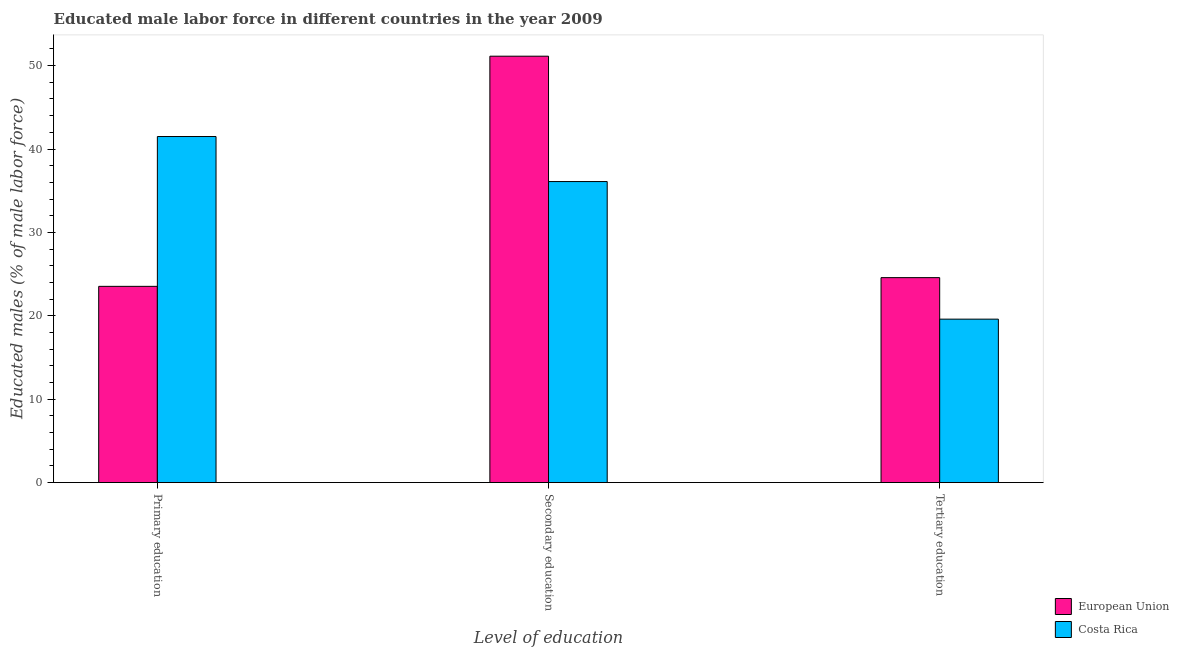How many different coloured bars are there?
Your answer should be compact. 2. How many groups of bars are there?
Give a very brief answer. 3. Are the number of bars per tick equal to the number of legend labels?
Your response must be concise. Yes. How many bars are there on the 1st tick from the left?
Provide a succinct answer. 2. What is the label of the 2nd group of bars from the left?
Your answer should be compact. Secondary education. What is the percentage of male labor force who received primary education in European Union?
Keep it short and to the point. 23.53. Across all countries, what is the maximum percentage of male labor force who received primary education?
Give a very brief answer. 41.5. Across all countries, what is the minimum percentage of male labor force who received secondary education?
Make the answer very short. 36.1. In which country was the percentage of male labor force who received tertiary education minimum?
Give a very brief answer. Costa Rica. What is the total percentage of male labor force who received primary education in the graph?
Provide a succinct answer. 65.03. What is the difference between the percentage of male labor force who received secondary education in Costa Rica and that in European Union?
Make the answer very short. -15.03. What is the difference between the percentage of male labor force who received primary education in European Union and the percentage of male labor force who received tertiary education in Costa Rica?
Offer a terse response. 3.93. What is the average percentage of male labor force who received tertiary education per country?
Provide a succinct answer. 22.09. What is the difference between the percentage of male labor force who received secondary education and percentage of male labor force who received tertiary education in European Union?
Keep it short and to the point. 26.55. What is the ratio of the percentage of male labor force who received primary education in European Union to that in Costa Rica?
Provide a succinct answer. 0.57. Is the percentage of male labor force who received primary education in Costa Rica less than that in European Union?
Make the answer very short. No. What is the difference between the highest and the second highest percentage of male labor force who received secondary education?
Offer a terse response. 15.03. What is the difference between the highest and the lowest percentage of male labor force who received tertiary education?
Provide a short and direct response. 4.98. Is the sum of the percentage of male labor force who received tertiary education in Costa Rica and European Union greater than the maximum percentage of male labor force who received primary education across all countries?
Make the answer very short. Yes. What does the 2nd bar from the right in Primary education represents?
Your response must be concise. European Union. How many bars are there?
Ensure brevity in your answer.  6. How many countries are there in the graph?
Ensure brevity in your answer.  2. What is the difference between two consecutive major ticks on the Y-axis?
Provide a short and direct response. 10. Are the values on the major ticks of Y-axis written in scientific E-notation?
Your answer should be compact. No. Where does the legend appear in the graph?
Offer a terse response. Bottom right. How many legend labels are there?
Your answer should be very brief. 2. What is the title of the graph?
Ensure brevity in your answer.  Educated male labor force in different countries in the year 2009. What is the label or title of the X-axis?
Make the answer very short. Level of education. What is the label or title of the Y-axis?
Provide a succinct answer. Educated males (% of male labor force). What is the Educated males (% of male labor force) in European Union in Primary education?
Ensure brevity in your answer.  23.53. What is the Educated males (% of male labor force) in Costa Rica in Primary education?
Keep it short and to the point. 41.5. What is the Educated males (% of male labor force) of European Union in Secondary education?
Make the answer very short. 51.13. What is the Educated males (% of male labor force) in Costa Rica in Secondary education?
Make the answer very short. 36.1. What is the Educated males (% of male labor force) in European Union in Tertiary education?
Offer a terse response. 24.58. What is the Educated males (% of male labor force) in Costa Rica in Tertiary education?
Provide a short and direct response. 19.6. Across all Level of education, what is the maximum Educated males (% of male labor force) in European Union?
Your response must be concise. 51.13. Across all Level of education, what is the maximum Educated males (% of male labor force) of Costa Rica?
Your response must be concise. 41.5. Across all Level of education, what is the minimum Educated males (% of male labor force) in European Union?
Make the answer very short. 23.53. Across all Level of education, what is the minimum Educated males (% of male labor force) in Costa Rica?
Make the answer very short. 19.6. What is the total Educated males (% of male labor force) in European Union in the graph?
Your answer should be very brief. 99.24. What is the total Educated males (% of male labor force) in Costa Rica in the graph?
Keep it short and to the point. 97.2. What is the difference between the Educated males (% of male labor force) in European Union in Primary education and that in Secondary education?
Give a very brief answer. -27.6. What is the difference between the Educated males (% of male labor force) of Costa Rica in Primary education and that in Secondary education?
Your answer should be compact. 5.4. What is the difference between the Educated males (% of male labor force) in European Union in Primary education and that in Tertiary education?
Give a very brief answer. -1.04. What is the difference between the Educated males (% of male labor force) in Costa Rica in Primary education and that in Tertiary education?
Ensure brevity in your answer.  21.9. What is the difference between the Educated males (% of male labor force) in European Union in Secondary education and that in Tertiary education?
Offer a terse response. 26.55. What is the difference between the Educated males (% of male labor force) of Costa Rica in Secondary education and that in Tertiary education?
Offer a terse response. 16.5. What is the difference between the Educated males (% of male labor force) of European Union in Primary education and the Educated males (% of male labor force) of Costa Rica in Secondary education?
Give a very brief answer. -12.57. What is the difference between the Educated males (% of male labor force) in European Union in Primary education and the Educated males (% of male labor force) in Costa Rica in Tertiary education?
Ensure brevity in your answer.  3.93. What is the difference between the Educated males (% of male labor force) in European Union in Secondary education and the Educated males (% of male labor force) in Costa Rica in Tertiary education?
Offer a terse response. 31.53. What is the average Educated males (% of male labor force) in European Union per Level of education?
Offer a very short reply. 33.08. What is the average Educated males (% of male labor force) of Costa Rica per Level of education?
Ensure brevity in your answer.  32.4. What is the difference between the Educated males (% of male labor force) of European Union and Educated males (% of male labor force) of Costa Rica in Primary education?
Your answer should be compact. -17.97. What is the difference between the Educated males (% of male labor force) in European Union and Educated males (% of male labor force) in Costa Rica in Secondary education?
Offer a very short reply. 15.03. What is the difference between the Educated males (% of male labor force) in European Union and Educated males (% of male labor force) in Costa Rica in Tertiary education?
Provide a short and direct response. 4.98. What is the ratio of the Educated males (% of male labor force) of European Union in Primary education to that in Secondary education?
Ensure brevity in your answer.  0.46. What is the ratio of the Educated males (% of male labor force) in Costa Rica in Primary education to that in Secondary education?
Your answer should be compact. 1.15. What is the ratio of the Educated males (% of male labor force) of European Union in Primary education to that in Tertiary education?
Ensure brevity in your answer.  0.96. What is the ratio of the Educated males (% of male labor force) in Costa Rica in Primary education to that in Tertiary education?
Offer a very short reply. 2.12. What is the ratio of the Educated males (% of male labor force) of European Union in Secondary education to that in Tertiary education?
Your answer should be compact. 2.08. What is the ratio of the Educated males (% of male labor force) in Costa Rica in Secondary education to that in Tertiary education?
Offer a very short reply. 1.84. What is the difference between the highest and the second highest Educated males (% of male labor force) in European Union?
Provide a succinct answer. 26.55. What is the difference between the highest and the second highest Educated males (% of male labor force) of Costa Rica?
Your response must be concise. 5.4. What is the difference between the highest and the lowest Educated males (% of male labor force) in European Union?
Make the answer very short. 27.6. What is the difference between the highest and the lowest Educated males (% of male labor force) of Costa Rica?
Your answer should be very brief. 21.9. 